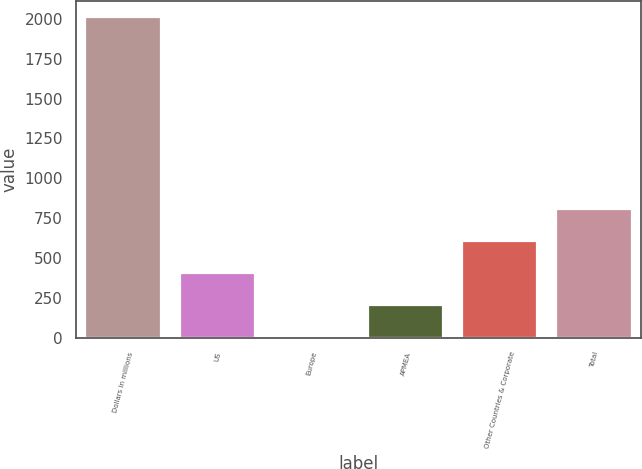Convert chart to OTSL. <chart><loc_0><loc_0><loc_500><loc_500><bar_chart><fcel>Dollars in millions<fcel>US<fcel>Europe<fcel>APMEA<fcel>Other Countries & Corporate<fcel>Total<nl><fcel>2009<fcel>404.2<fcel>3<fcel>203.6<fcel>604.8<fcel>805.4<nl></chart> 